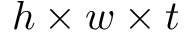<formula> <loc_0><loc_0><loc_500><loc_500>h \times w \times t</formula> 